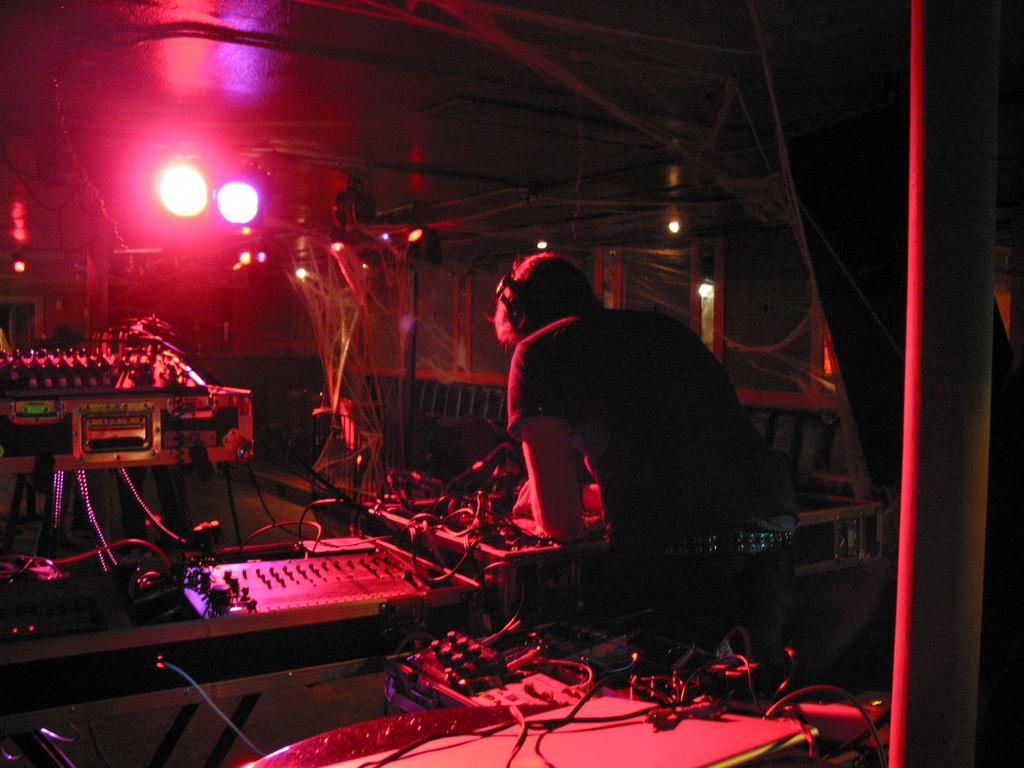What is the main subject of the image? There is a person standing in the image. What is the person wearing? The person is wearing clothes and headsets. What else can be seen in the image besides the person? There are cable wires, lights, and an electronic device present in the image. What type of brain can be seen in the image? There is no brain visible in the image. What noise is being made by the person in the image? The image does not provide any information about noise or sounds being made by the person. 